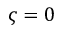Convert formula to latex. <formula><loc_0><loc_0><loc_500><loc_500>\varsigma = 0</formula> 